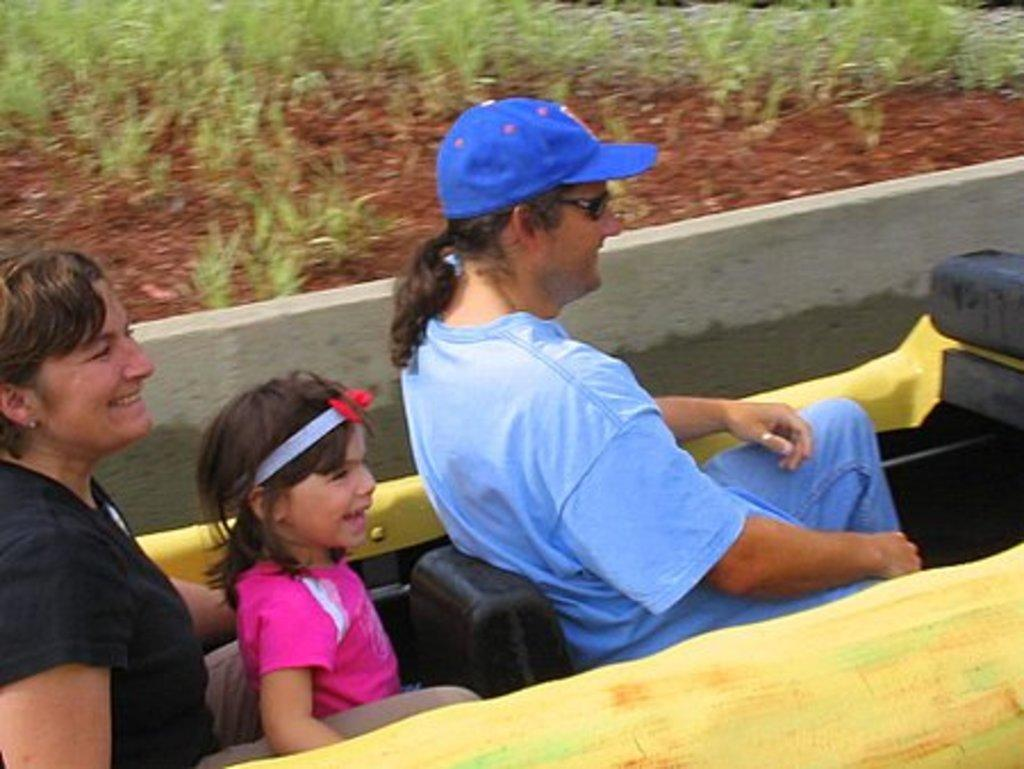How many people are sitting on the vehicle in the image? There are three persons sitting on the vehicle in the image. What can be seen in the background of the image? There are planets visible in the image. What type of structure is present in the image? There is a wall in the image. How do the friends behave in the image? The image does not mention friends, so we cannot determine their behavior. 